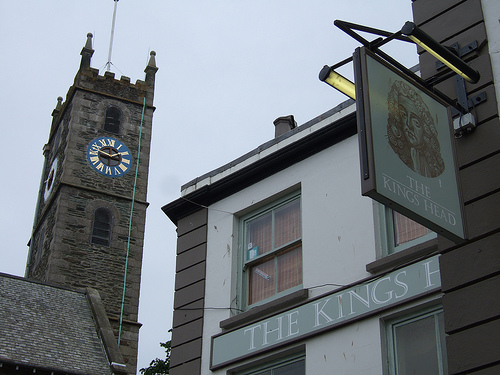Imagine you could step into the past, what would a day in this area look like several centuries ago? Stepping back several centuries, the area around the clock tower would be bustling with activity. Townsfolk would be engaged in daily commerce, with market stalls lining the streets, selling fresh produce, meats, and handcrafted goods. The sound of the town crier announcing news and events would fill the air, while horse-drawn carts and pedestrians navigated the narrow, cobblestone streets. The clock tower's bells would toll the hours, marking time for the residents going about their lives amidst this vibrant, communal atmosphere. What would you imagine is the purpose of the sign that reads 'THE KINGS HEAD'? The sign for 'THE KINGS HEAD' likely signifies a popular inn or pub, historically a central hub for social interaction within the community. Such establishments served as places for travelers to rest and locals to gather, sharing stories, meals, and drinks. It's probable this venue has been a key part of the town's social fabric for many years. 